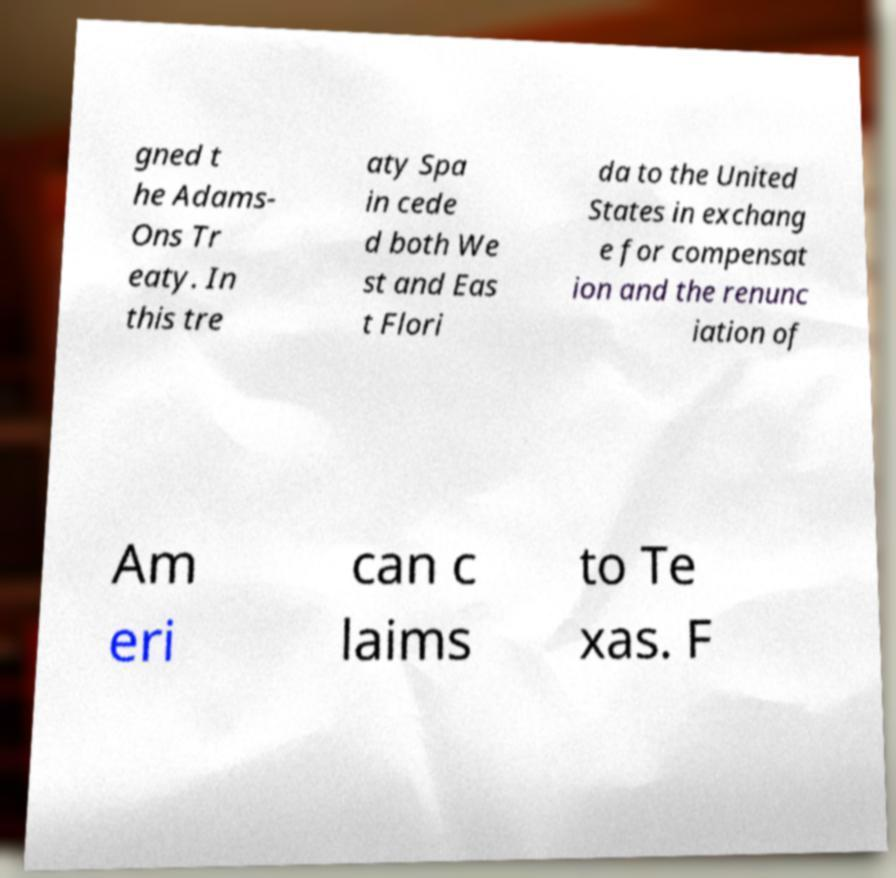Please identify and transcribe the text found in this image. gned t he Adams- Ons Tr eaty. In this tre aty Spa in cede d both We st and Eas t Flori da to the United States in exchang e for compensat ion and the renunc iation of Am eri can c laims to Te xas. F 